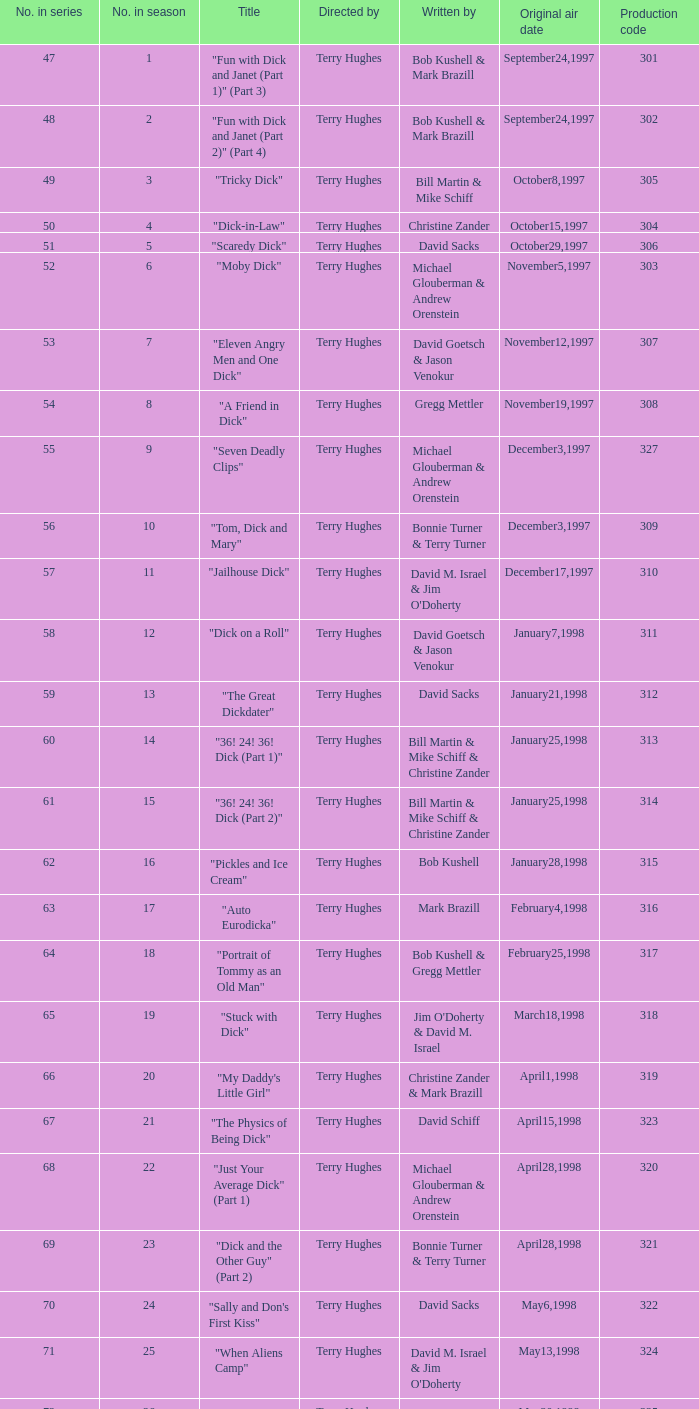Who were the scribes of the episode titled "tricky dick"? Bill Martin & Mike Schiff. 